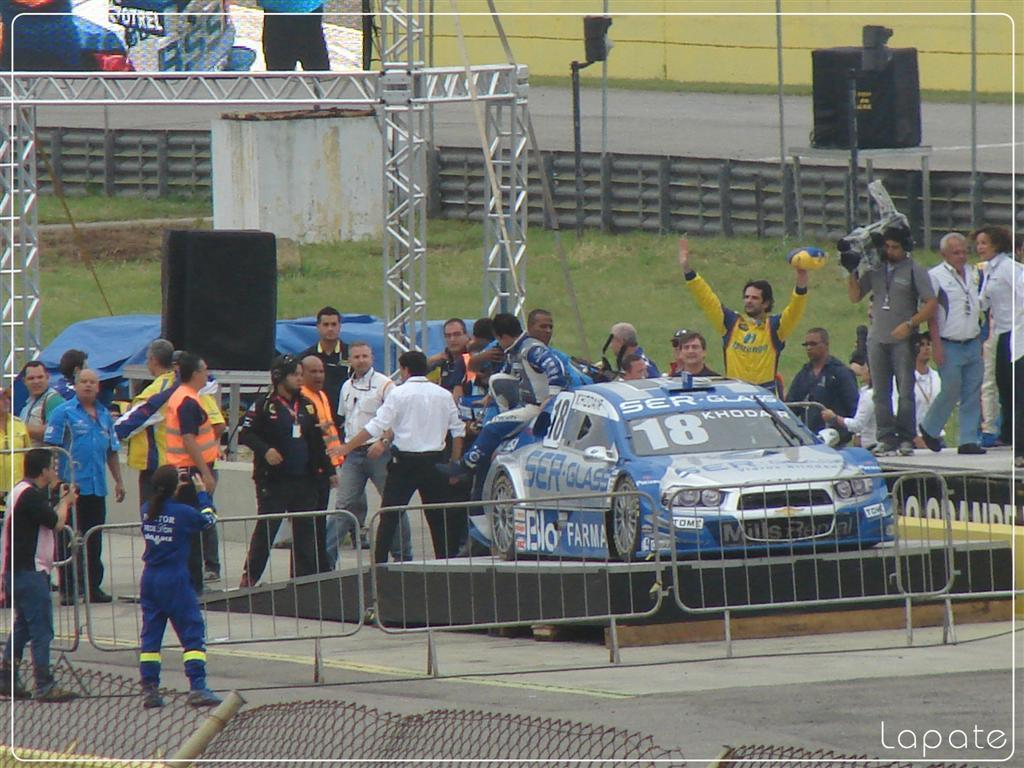What are the people in the image doing? The people in the image are standing. What is the man holding in the image? The man is holding a camera. What can be seen in the background of the image? There is a fence, a car, grass, a screen, and rods visible in the background of the image. What type of tomatoes are being grown on the screen in the background? There are no tomatoes present in the image, and the screen is not a growing area for plants. 